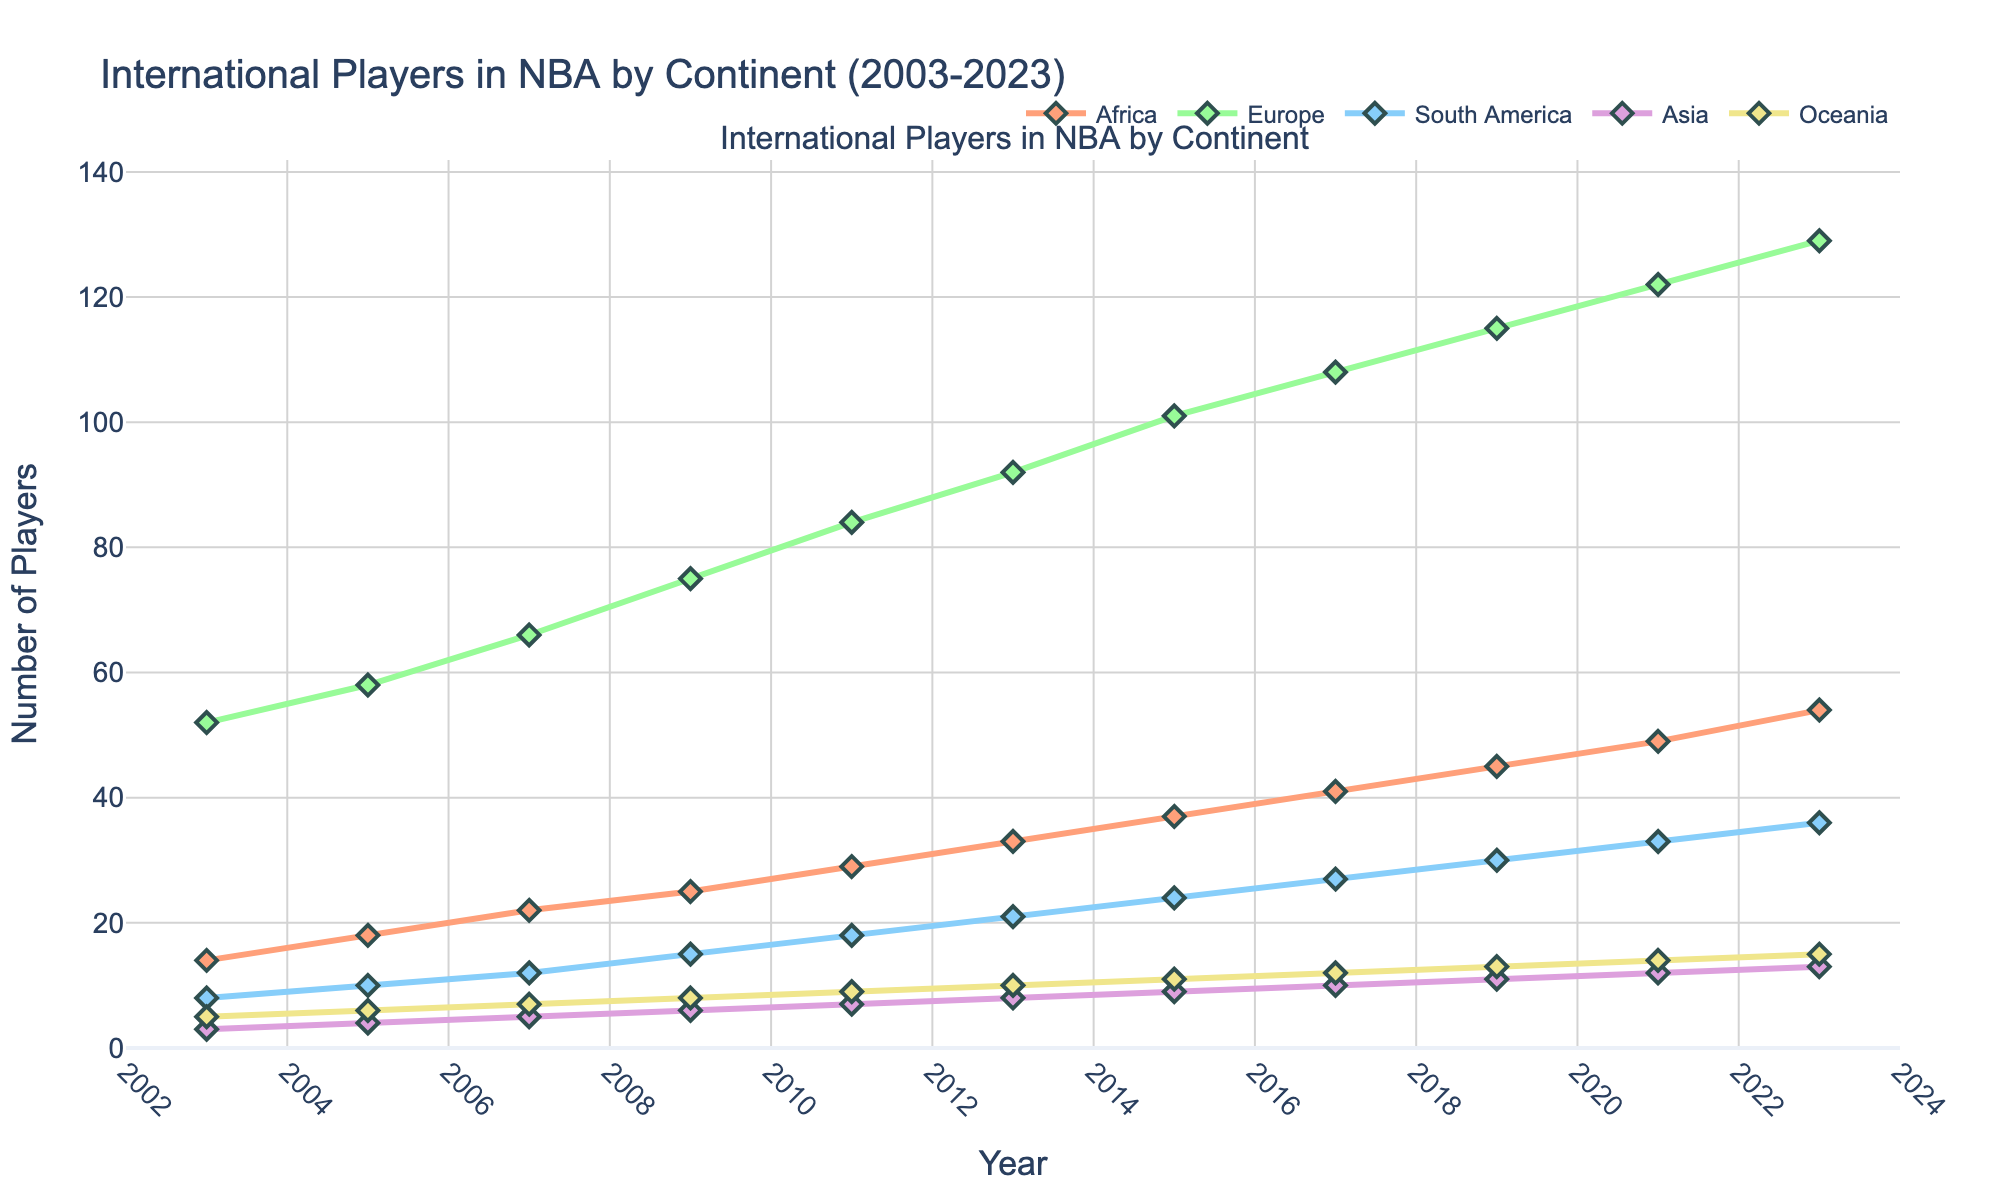How many international players from Africa were in the NBA in 2011 and how many more were there in 2023? The number of African players in 2011 is 29. In 2023, there are 54. The difference is 54 - 29
Answer: 25 Which continent had the highest increase in the number of players from 2003 to 2023? To determine the increase, subtract the number of players in 2003 from the number in 2023 for each continent. Europe: 129-52=77, Africa: 54-14=40, South America: 36-8=28, Asia: 13-3=10, Oceania: 15-5=10. Europe has the highest increase.
Answer: Europe Which two continents had the smallest difference in the number of players in 2003? In 2003, the numbers are Africa: 14, Europe: 52, South America: 8, Asia: 3, and Oceania: 5. Calculate the absolute differences: Africa-Europe: 38, Africa-South America: 6, Africa-Asia: 11, Africa-Oceania: 9, Europe-South America: 44, Europe-Asia: 49, Europe-Oceania: 47, South America-Asia: 5, South America-Oceania: 3, Asia-Oceania: 2. Asia and Oceania have the smallest difference.
Answer: Asia and Oceania Which color line represents the continent with the second highest number of players in 2023? From the data, Europe has the highest number of players in 2023 with 129, followed by Africa with 54. The plot shows Africa with the reddish-orange color line.
Answer: Reddish-orange In which year did Asia have the same number of players as Oceania? According to the data, Asia and Oceania both had 13 players in 2023.
Answer: 2023 Which continent had a steady increase in the number of players every two years without any drop? By checking each continent: Africa's player count increased steadily from 2003 to 2023.
Answer: Africa In 2015, how many players in total were from continents other than Europe? Add up the number of players from Africa, South America, Asia, and Oceania in 2015: Africa: 37, South America: 24, Asia: 9, Oceania: 11. Total = 37 + 24 + 9 + 11
Answer: 81 